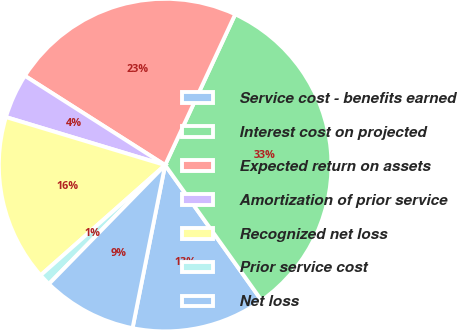<chart> <loc_0><loc_0><loc_500><loc_500><pie_chart><fcel>Service cost - benefits earned<fcel>Interest cost on projected<fcel>Expected return on assets<fcel>Amortization of prior service<fcel>Recognized net loss<fcel>Prior service cost<fcel>Net loss<nl><fcel>12.99%<fcel>33.22%<fcel>22.9%<fcel>4.36%<fcel>16.19%<fcel>1.15%<fcel>9.18%<nl></chart> 